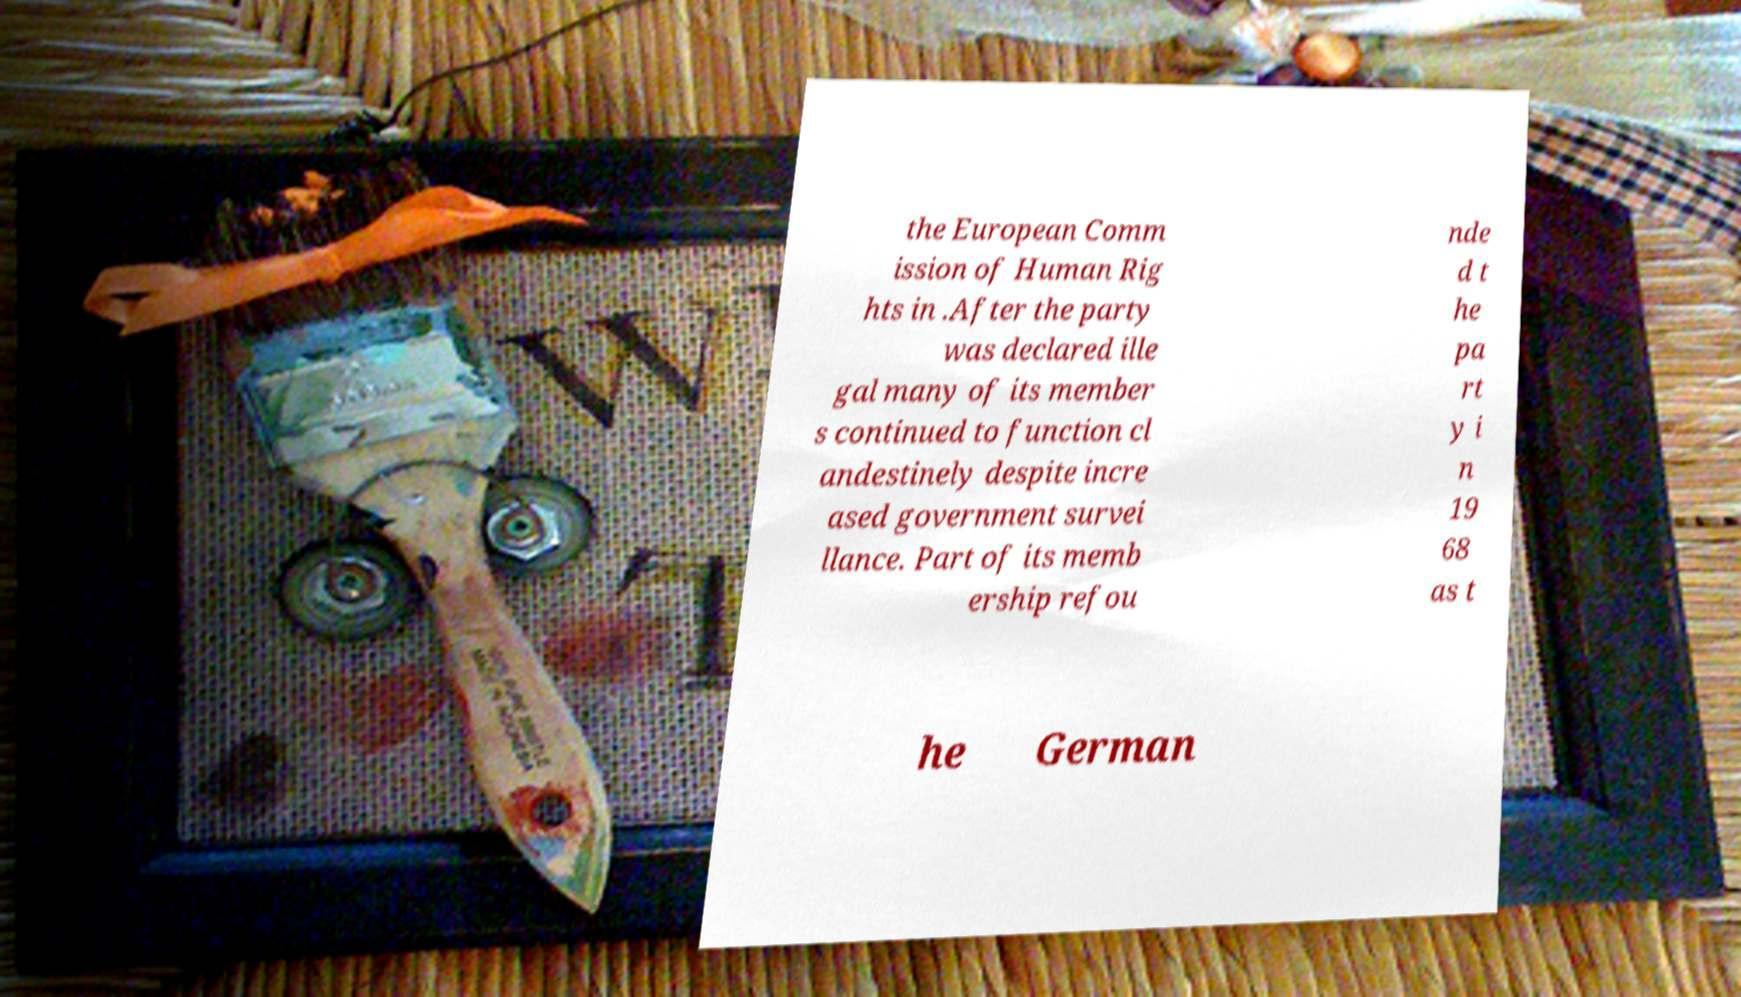There's text embedded in this image that I need extracted. Can you transcribe it verbatim? the European Comm ission of Human Rig hts in .After the party was declared ille gal many of its member s continued to function cl andestinely despite incre ased government survei llance. Part of its memb ership refou nde d t he pa rt y i n 19 68 as t he German 